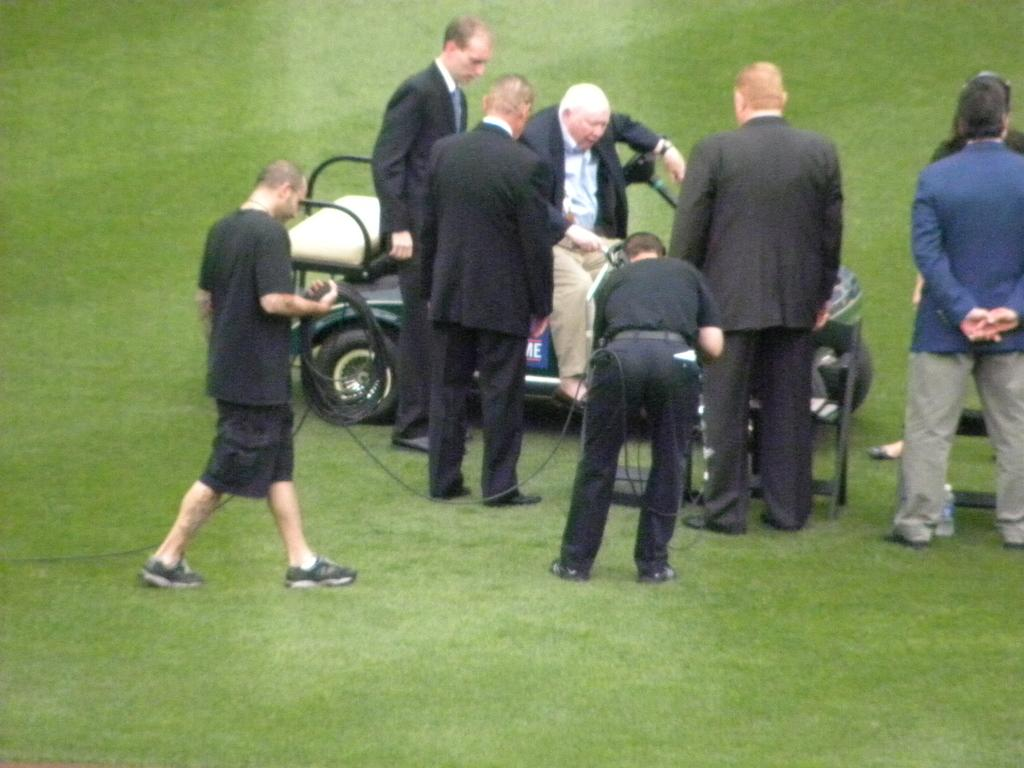What type of location is shown in the image? The image depicts a garden. What is the man in the image doing? The man is sitting on a vehicle in the image. Are there any other people present in the image? Yes, there are other people standing around the vehicle. What is the man sitting on the vehicle wearing? The man is wearing a black coat. What type of tray is being used to sort items in the image? There is no tray or sorting activity present in the image. Is there any indication of a war or conflict in the image? No, there is no indication of a war or conflict in the image. 